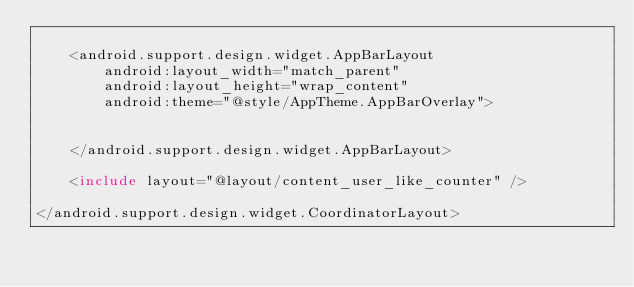Convert code to text. <code><loc_0><loc_0><loc_500><loc_500><_XML_>
    <android.support.design.widget.AppBarLayout
        android:layout_width="match_parent"
        android:layout_height="wrap_content"
        android:theme="@style/AppTheme.AppBarOverlay">


    </android.support.design.widget.AppBarLayout>

    <include layout="@layout/content_user_like_counter" />

</android.support.design.widget.CoordinatorLayout>
</code> 